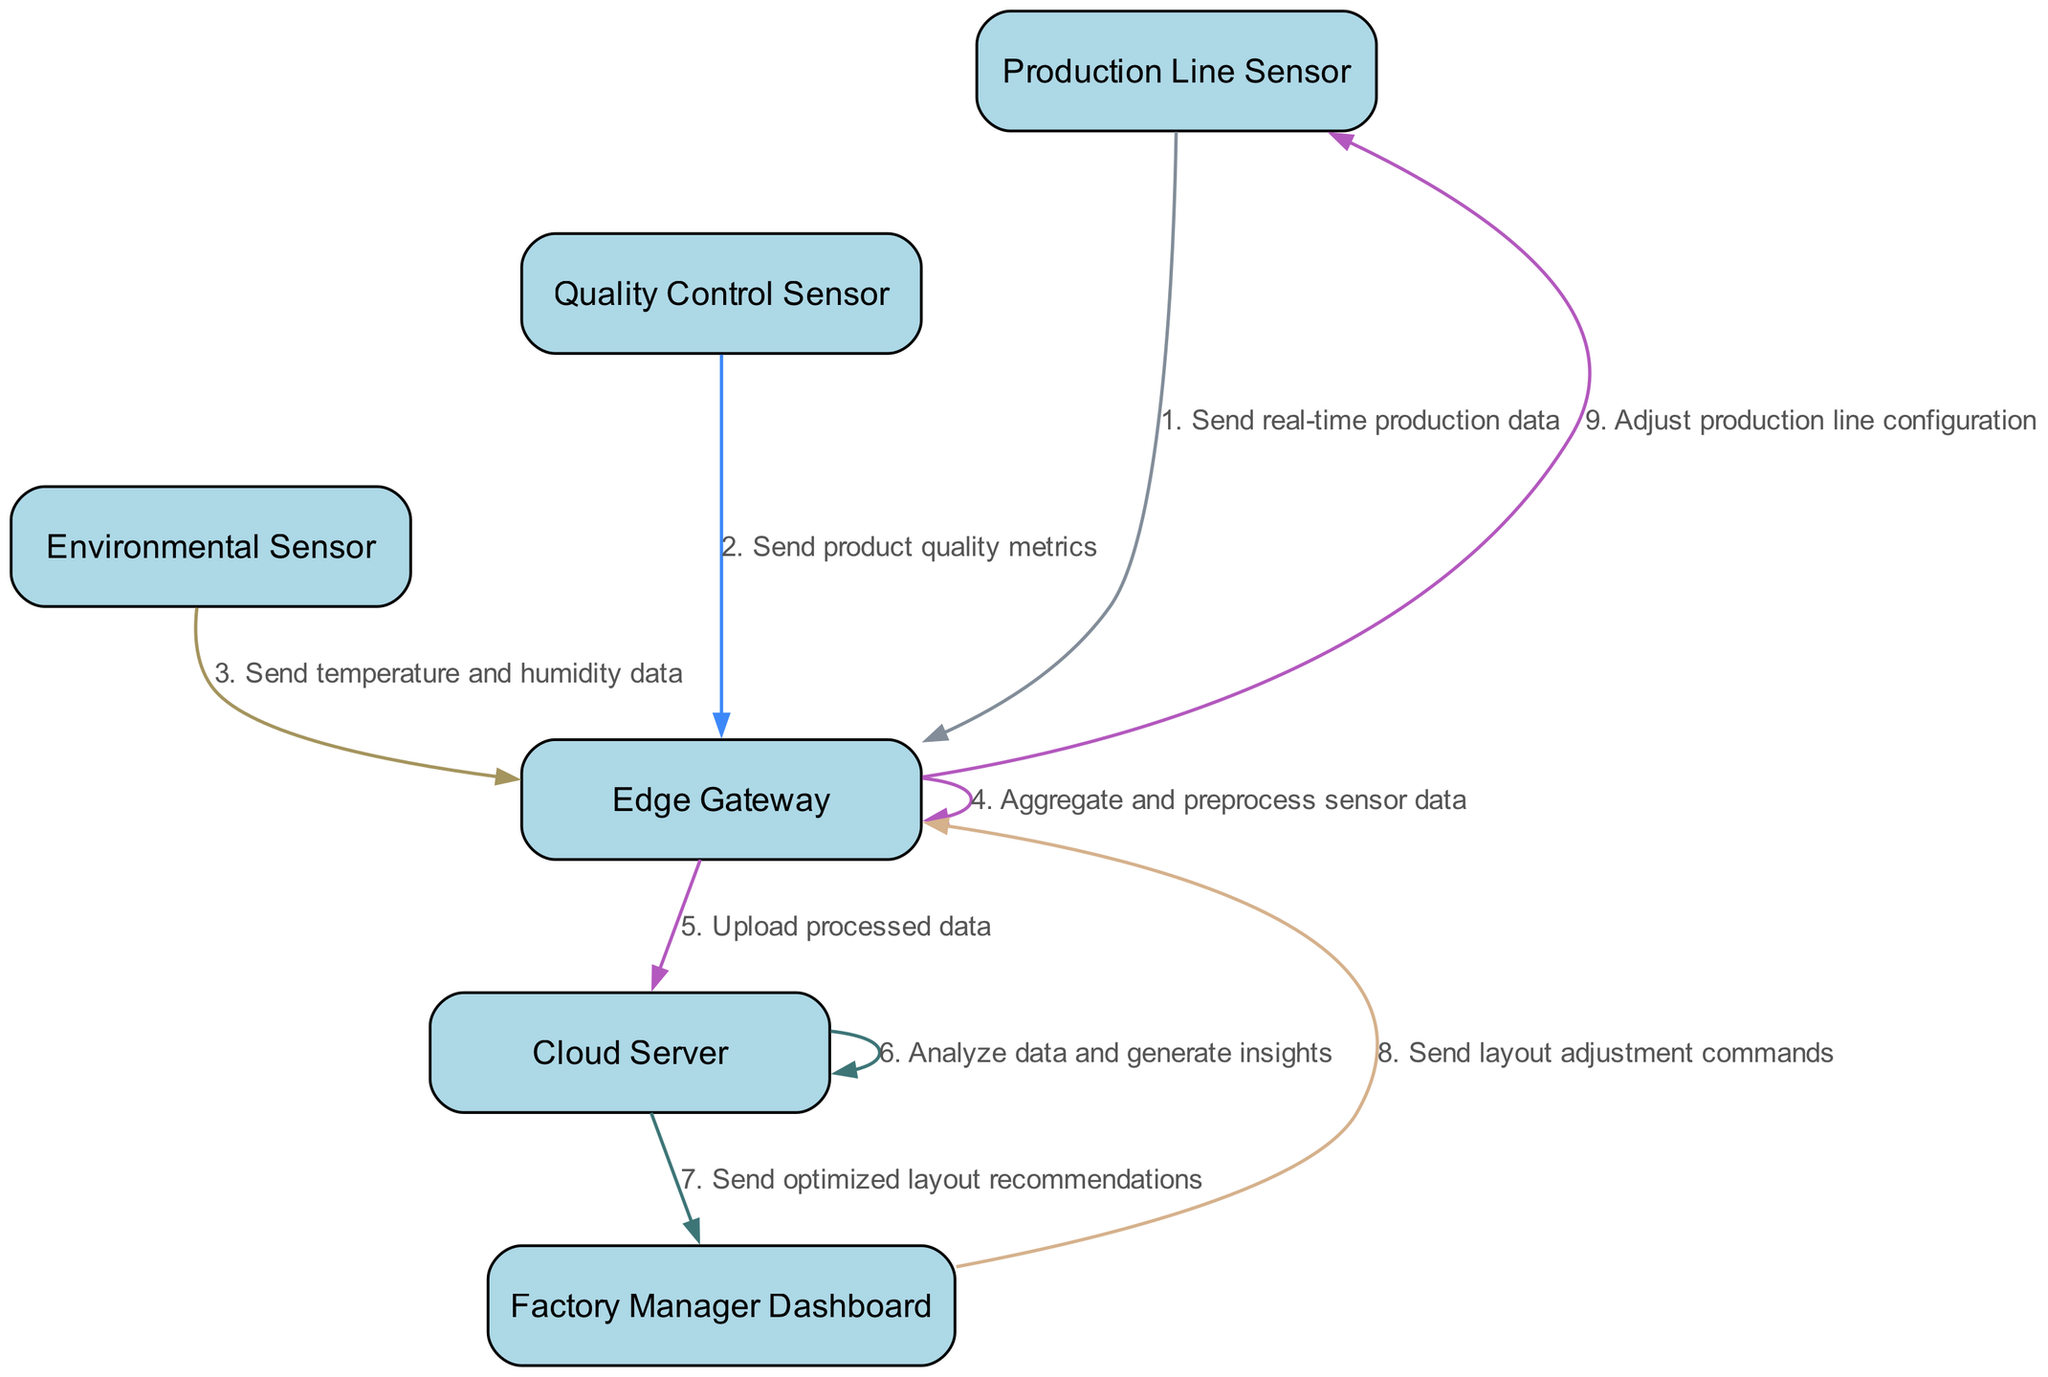What is the first message sent in the sequence? The first message sent is from the Production Line Sensor to the Edge Gateway, stating "Send real-time production data". This can be identified as the very first edge drawn in the diagram.
Answer: Send real-time production data How many participants are involved in the communication sequence? There are six participants listed at the beginning of the diagram: Production Line Sensor, Quality Control Sensor, Environmental Sensor, Edge Gateway, Cloud Server, and Factory Manager Dashboard. Count these participants to find the total.
Answer: 6 Which sensor sends product quality metrics? The Quality Control Sensor is identified as the sender of the message "Send product quality metrics" directed to the Edge Gateway, which is the second message in the sequence.
Answer: Quality Control Sensor What message does the Cloud Server send to the Factory Manager Dashboard? The Cloud Server sends the message "Send optimized layout recommendations" to the Factory Manager Dashboard. This is noted in the penultimate step of the sequence.
Answer: Send optimized layout recommendations What is the purpose of the Edge Gateway in the communication sequence? The Edge Gateway's role is to aggregate and preprocess sensor data received from various sensors. It sends processed data to the Cloud Server, as shown in the sequence.
Answer: Aggregate and preprocess sensor data How many messages are exchanged between the Cloud Server and the Factory Manager Dashboard? There are two messages exchanged in total: one from the Cloud Server to the Factory Manager Dashboard and one return command from the Factory Manager Dashboard back to the Edge Gateway. You can confirm this by tracing the edges in the sequence.
Answer: 2 What action does the Edge Gateway take after receiving layout adjustment commands? After receiving layout adjustment commands from the Factory Manager Dashboard, the Edge Gateway sends a message to the Production Line Sensor with the instruction "Adjust production line configuration".
Answer: Adjust production line configuration Which participant processes the data and generates insights? The Cloud Server processes the data and generates insights, as indicated by the message "Analyze data and generate insights". This is clearly spelled out in one of the arrows leading from the Cloud Server to itself.
Answer: Cloud Server What is the second message sent in this sequence? The second message is sent from the Quality Control Sensor to the Edge Gateway, which communicates the product quality metrics. This can be derived by examining the sequence order of messages.
Answer: Send product quality metrics 